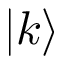Convert formula to latex. <formula><loc_0><loc_0><loc_500><loc_500>| k \rangle</formula> 